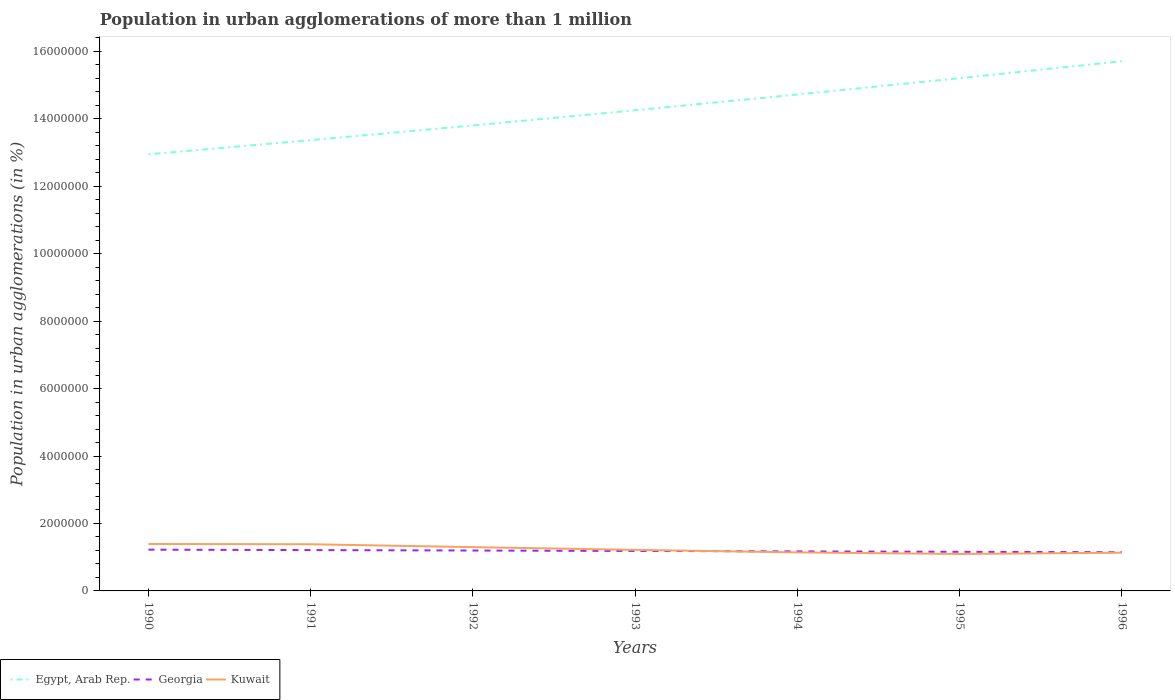How many different coloured lines are there?
Give a very brief answer. 3. Does the line corresponding to Kuwait intersect with the line corresponding to Egypt, Arab Rep.?
Your answer should be very brief. No. Is the number of lines equal to the number of legend labels?
Make the answer very short. Yes. Across all years, what is the maximum population in urban agglomerations in Egypt, Arab Rep.?
Make the answer very short. 1.29e+07. In which year was the population in urban agglomerations in Kuwait maximum?
Give a very brief answer. 1995. What is the total population in urban agglomerations in Georgia in the graph?
Keep it short and to the point. 1.29e+04. What is the difference between the highest and the second highest population in urban agglomerations in Egypt, Arab Rep.?
Offer a terse response. 2.76e+06. What is the difference between the highest and the lowest population in urban agglomerations in Georgia?
Provide a short and direct response. 3. Is the population in urban agglomerations in Kuwait strictly greater than the population in urban agglomerations in Egypt, Arab Rep. over the years?
Offer a very short reply. Yes. How many lines are there?
Give a very brief answer. 3. How many years are there in the graph?
Offer a terse response. 7. Are the values on the major ticks of Y-axis written in scientific E-notation?
Your answer should be very brief. No. How many legend labels are there?
Your answer should be compact. 3. What is the title of the graph?
Your answer should be very brief. Population in urban agglomerations of more than 1 million. What is the label or title of the Y-axis?
Provide a short and direct response. Population in urban agglomerations (in %). What is the Population in urban agglomerations (in %) in Egypt, Arab Rep. in 1990?
Make the answer very short. 1.29e+07. What is the Population in urban agglomerations (in %) in Georgia in 1990?
Give a very brief answer. 1.22e+06. What is the Population in urban agglomerations (in %) of Kuwait in 1990?
Your response must be concise. 1.39e+06. What is the Population in urban agglomerations (in %) in Egypt, Arab Rep. in 1991?
Offer a terse response. 1.34e+07. What is the Population in urban agglomerations (in %) in Georgia in 1991?
Give a very brief answer. 1.21e+06. What is the Population in urban agglomerations (in %) in Kuwait in 1991?
Give a very brief answer. 1.38e+06. What is the Population in urban agglomerations (in %) in Egypt, Arab Rep. in 1992?
Provide a succinct answer. 1.38e+07. What is the Population in urban agglomerations (in %) of Georgia in 1992?
Ensure brevity in your answer.  1.20e+06. What is the Population in urban agglomerations (in %) of Kuwait in 1992?
Your response must be concise. 1.30e+06. What is the Population in urban agglomerations (in %) of Egypt, Arab Rep. in 1993?
Provide a short and direct response. 1.43e+07. What is the Population in urban agglomerations (in %) in Georgia in 1993?
Your answer should be compact. 1.19e+06. What is the Population in urban agglomerations (in %) in Kuwait in 1993?
Offer a very short reply. 1.22e+06. What is the Population in urban agglomerations (in %) of Egypt, Arab Rep. in 1994?
Your response must be concise. 1.47e+07. What is the Population in urban agglomerations (in %) in Georgia in 1994?
Your response must be concise. 1.17e+06. What is the Population in urban agglomerations (in %) of Kuwait in 1994?
Offer a terse response. 1.14e+06. What is the Population in urban agglomerations (in %) in Egypt, Arab Rep. in 1995?
Your answer should be compact. 1.52e+07. What is the Population in urban agglomerations (in %) of Georgia in 1995?
Make the answer very short. 1.16e+06. What is the Population in urban agglomerations (in %) in Kuwait in 1995?
Your response must be concise. 1.10e+06. What is the Population in urban agglomerations (in %) in Egypt, Arab Rep. in 1996?
Your answer should be compact. 1.57e+07. What is the Population in urban agglomerations (in %) in Georgia in 1996?
Offer a very short reply. 1.15e+06. What is the Population in urban agglomerations (in %) in Kuwait in 1996?
Offer a terse response. 1.13e+06. Across all years, what is the maximum Population in urban agglomerations (in %) of Egypt, Arab Rep.?
Give a very brief answer. 1.57e+07. Across all years, what is the maximum Population in urban agglomerations (in %) of Georgia?
Keep it short and to the point. 1.22e+06. Across all years, what is the maximum Population in urban agglomerations (in %) in Kuwait?
Your answer should be very brief. 1.39e+06. Across all years, what is the minimum Population in urban agglomerations (in %) of Egypt, Arab Rep.?
Make the answer very short. 1.29e+07. Across all years, what is the minimum Population in urban agglomerations (in %) in Georgia?
Keep it short and to the point. 1.15e+06. Across all years, what is the minimum Population in urban agglomerations (in %) of Kuwait?
Make the answer very short. 1.10e+06. What is the total Population in urban agglomerations (in %) in Egypt, Arab Rep. in the graph?
Make the answer very short. 1.00e+08. What is the total Population in urban agglomerations (in %) of Georgia in the graph?
Offer a very short reply. 8.30e+06. What is the total Population in urban agglomerations (in %) in Kuwait in the graph?
Keep it short and to the point. 8.66e+06. What is the difference between the Population in urban agglomerations (in %) of Egypt, Arab Rep. in 1990 and that in 1991?
Your answer should be very brief. -4.20e+05. What is the difference between the Population in urban agglomerations (in %) in Georgia in 1990 and that in 1991?
Your response must be concise. 1.30e+04. What is the difference between the Population in urban agglomerations (in %) in Kuwait in 1990 and that in 1991?
Provide a short and direct response. 7756. What is the difference between the Population in urban agglomerations (in %) in Egypt, Arab Rep. in 1990 and that in 1992?
Provide a short and direct response. -8.55e+05. What is the difference between the Population in urban agglomerations (in %) of Georgia in 1990 and that in 1992?
Offer a terse response. 2.59e+04. What is the difference between the Population in urban agglomerations (in %) of Kuwait in 1990 and that in 1992?
Offer a very short reply. 9.37e+04. What is the difference between the Population in urban agglomerations (in %) of Egypt, Arab Rep. in 1990 and that in 1993?
Your answer should be very brief. -1.31e+06. What is the difference between the Population in urban agglomerations (in %) of Georgia in 1990 and that in 1993?
Offer a very short reply. 3.86e+04. What is the difference between the Population in urban agglomerations (in %) in Kuwait in 1990 and that in 1993?
Provide a short and direct response. 1.74e+05. What is the difference between the Population in urban agglomerations (in %) in Egypt, Arab Rep. in 1990 and that in 1994?
Your answer should be very brief. -1.77e+06. What is the difference between the Population in urban agglomerations (in %) in Georgia in 1990 and that in 1994?
Ensure brevity in your answer.  5.12e+04. What is the difference between the Population in urban agglomerations (in %) of Kuwait in 1990 and that in 1994?
Make the answer very short. 2.50e+05. What is the difference between the Population in urban agglomerations (in %) in Egypt, Arab Rep. in 1990 and that in 1995?
Offer a terse response. -2.26e+06. What is the difference between the Population in urban agglomerations (in %) in Georgia in 1990 and that in 1995?
Make the answer very short. 6.37e+04. What is the difference between the Population in urban agglomerations (in %) in Kuwait in 1990 and that in 1995?
Provide a short and direct response. 2.97e+05. What is the difference between the Population in urban agglomerations (in %) of Egypt, Arab Rep. in 1990 and that in 1996?
Provide a succinct answer. -2.76e+06. What is the difference between the Population in urban agglomerations (in %) of Georgia in 1990 and that in 1996?
Give a very brief answer. 7.60e+04. What is the difference between the Population in urban agglomerations (in %) of Kuwait in 1990 and that in 1996?
Offer a terse response. 2.58e+05. What is the difference between the Population in urban agglomerations (in %) in Egypt, Arab Rep. in 1991 and that in 1992?
Your answer should be compact. -4.36e+05. What is the difference between the Population in urban agglomerations (in %) in Georgia in 1991 and that in 1992?
Offer a very short reply. 1.29e+04. What is the difference between the Population in urban agglomerations (in %) in Kuwait in 1991 and that in 1992?
Make the answer very short. 8.60e+04. What is the difference between the Population in urban agglomerations (in %) in Egypt, Arab Rep. in 1991 and that in 1993?
Your response must be concise. -8.86e+05. What is the difference between the Population in urban agglomerations (in %) in Georgia in 1991 and that in 1993?
Give a very brief answer. 2.56e+04. What is the difference between the Population in urban agglomerations (in %) of Kuwait in 1991 and that in 1993?
Give a very brief answer. 1.66e+05. What is the difference between the Population in urban agglomerations (in %) of Egypt, Arab Rep. in 1991 and that in 1994?
Offer a terse response. -1.35e+06. What is the difference between the Population in urban agglomerations (in %) of Georgia in 1991 and that in 1994?
Ensure brevity in your answer.  3.82e+04. What is the difference between the Population in urban agglomerations (in %) of Kuwait in 1991 and that in 1994?
Keep it short and to the point. 2.42e+05. What is the difference between the Population in urban agglomerations (in %) in Egypt, Arab Rep. in 1991 and that in 1995?
Offer a very short reply. -1.84e+06. What is the difference between the Population in urban agglomerations (in %) of Georgia in 1991 and that in 1995?
Keep it short and to the point. 5.07e+04. What is the difference between the Population in urban agglomerations (in %) in Kuwait in 1991 and that in 1995?
Provide a succinct answer. 2.89e+05. What is the difference between the Population in urban agglomerations (in %) in Egypt, Arab Rep. in 1991 and that in 1996?
Keep it short and to the point. -2.34e+06. What is the difference between the Population in urban agglomerations (in %) of Georgia in 1991 and that in 1996?
Ensure brevity in your answer.  6.30e+04. What is the difference between the Population in urban agglomerations (in %) of Kuwait in 1991 and that in 1996?
Offer a very short reply. 2.51e+05. What is the difference between the Population in urban agglomerations (in %) in Egypt, Arab Rep. in 1992 and that in 1993?
Offer a very short reply. -4.50e+05. What is the difference between the Population in urban agglomerations (in %) of Georgia in 1992 and that in 1993?
Provide a succinct answer. 1.27e+04. What is the difference between the Population in urban agglomerations (in %) in Kuwait in 1992 and that in 1993?
Keep it short and to the point. 8.04e+04. What is the difference between the Population in urban agglomerations (in %) in Egypt, Arab Rep. in 1992 and that in 1994?
Keep it short and to the point. -9.18e+05. What is the difference between the Population in urban agglomerations (in %) in Georgia in 1992 and that in 1994?
Your response must be concise. 2.53e+04. What is the difference between the Population in urban agglomerations (in %) in Kuwait in 1992 and that in 1994?
Your response must be concise. 1.56e+05. What is the difference between the Population in urban agglomerations (in %) in Egypt, Arab Rep. in 1992 and that in 1995?
Your answer should be very brief. -1.40e+06. What is the difference between the Population in urban agglomerations (in %) of Georgia in 1992 and that in 1995?
Keep it short and to the point. 3.78e+04. What is the difference between the Population in urban agglomerations (in %) of Kuwait in 1992 and that in 1995?
Offer a terse response. 2.03e+05. What is the difference between the Population in urban agglomerations (in %) of Egypt, Arab Rep. in 1992 and that in 1996?
Give a very brief answer. -1.91e+06. What is the difference between the Population in urban agglomerations (in %) in Georgia in 1992 and that in 1996?
Provide a short and direct response. 5.01e+04. What is the difference between the Population in urban agglomerations (in %) of Kuwait in 1992 and that in 1996?
Offer a very short reply. 1.65e+05. What is the difference between the Population in urban agglomerations (in %) in Egypt, Arab Rep. in 1993 and that in 1994?
Your answer should be compact. -4.67e+05. What is the difference between the Population in urban agglomerations (in %) in Georgia in 1993 and that in 1994?
Give a very brief answer. 1.26e+04. What is the difference between the Population in urban agglomerations (in %) of Kuwait in 1993 and that in 1994?
Provide a succinct answer. 7.55e+04. What is the difference between the Population in urban agglomerations (in %) of Egypt, Arab Rep. in 1993 and that in 1995?
Give a very brief answer. -9.52e+05. What is the difference between the Population in urban agglomerations (in %) in Georgia in 1993 and that in 1995?
Provide a succinct answer. 2.51e+04. What is the difference between the Population in urban agglomerations (in %) of Kuwait in 1993 and that in 1995?
Your answer should be very brief. 1.22e+05. What is the difference between the Population in urban agglomerations (in %) of Egypt, Arab Rep. in 1993 and that in 1996?
Offer a terse response. -1.45e+06. What is the difference between the Population in urban agglomerations (in %) of Georgia in 1993 and that in 1996?
Your response must be concise. 3.74e+04. What is the difference between the Population in urban agglomerations (in %) of Kuwait in 1993 and that in 1996?
Ensure brevity in your answer.  8.42e+04. What is the difference between the Population in urban agglomerations (in %) of Egypt, Arab Rep. in 1994 and that in 1995?
Your answer should be compact. -4.84e+05. What is the difference between the Population in urban agglomerations (in %) of Georgia in 1994 and that in 1995?
Give a very brief answer. 1.25e+04. What is the difference between the Population in urban agglomerations (in %) of Kuwait in 1994 and that in 1995?
Your answer should be very brief. 4.69e+04. What is the difference between the Population in urban agglomerations (in %) of Egypt, Arab Rep. in 1994 and that in 1996?
Provide a short and direct response. -9.87e+05. What is the difference between the Population in urban agglomerations (in %) in Georgia in 1994 and that in 1996?
Offer a terse response. 2.48e+04. What is the difference between the Population in urban agglomerations (in %) in Kuwait in 1994 and that in 1996?
Provide a succinct answer. 8671. What is the difference between the Population in urban agglomerations (in %) of Egypt, Arab Rep. in 1995 and that in 1996?
Ensure brevity in your answer.  -5.03e+05. What is the difference between the Population in urban agglomerations (in %) of Georgia in 1995 and that in 1996?
Give a very brief answer. 1.23e+04. What is the difference between the Population in urban agglomerations (in %) of Kuwait in 1995 and that in 1996?
Provide a short and direct response. -3.82e+04. What is the difference between the Population in urban agglomerations (in %) of Egypt, Arab Rep. in 1990 and the Population in urban agglomerations (in %) of Georgia in 1991?
Your answer should be compact. 1.17e+07. What is the difference between the Population in urban agglomerations (in %) of Egypt, Arab Rep. in 1990 and the Population in urban agglomerations (in %) of Kuwait in 1991?
Your response must be concise. 1.16e+07. What is the difference between the Population in urban agglomerations (in %) of Georgia in 1990 and the Population in urban agglomerations (in %) of Kuwait in 1991?
Offer a very short reply. -1.60e+05. What is the difference between the Population in urban agglomerations (in %) of Egypt, Arab Rep. in 1990 and the Population in urban agglomerations (in %) of Georgia in 1992?
Your answer should be compact. 1.18e+07. What is the difference between the Population in urban agglomerations (in %) of Egypt, Arab Rep. in 1990 and the Population in urban agglomerations (in %) of Kuwait in 1992?
Offer a terse response. 1.16e+07. What is the difference between the Population in urban agglomerations (in %) in Georgia in 1990 and the Population in urban agglomerations (in %) in Kuwait in 1992?
Make the answer very short. -7.43e+04. What is the difference between the Population in urban agglomerations (in %) in Egypt, Arab Rep. in 1990 and the Population in urban agglomerations (in %) in Georgia in 1993?
Your response must be concise. 1.18e+07. What is the difference between the Population in urban agglomerations (in %) of Egypt, Arab Rep. in 1990 and the Population in urban agglomerations (in %) of Kuwait in 1993?
Ensure brevity in your answer.  1.17e+07. What is the difference between the Population in urban agglomerations (in %) in Georgia in 1990 and the Population in urban agglomerations (in %) in Kuwait in 1993?
Ensure brevity in your answer.  6080. What is the difference between the Population in urban agglomerations (in %) of Egypt, Arab Rep. in 1990 and the Population in urban agglomerations (in %) of Georgia in 1994?
Offer a very short reply. 1.18e+07. What is the difference between the Population in urban agglomerations (in %) in Egypt, Arab Rep. in 1990 and the Population in urban agglomerations (in %) in Kuwait in 1994?
Your answer should be very brief. 1.18e+07. What is the difference between the Population in urban agglomerations (in %) of Georgia in 1990 and the Population in urban agglomerations (in %) of Kuwait in 1994?
Your response must be concise. 8.16e+04. What is the difference between the Population in urban agglomerations (in %) in Egypt, Arab Rep. in 1990 and the Population in urban agglomerations (in %) in Georgia in 1995?
Keep it short and to the point. 1.18e+07. What is the difference between the Population in urban agglomerations (in %) in Egypt, Arab Rep. in 1990 and the Population in urban agglomerations (in %) in Kuwait in 1995?
Ensure brevity in your answer.  1.19e+07. What is the difference between the Population in urban agglomerations (in %) of Georgia in 1990 and the Population in urban agglomerations (in %) of Kuwait in 1995?
Keep it short and to the point. 1.29e+05. What is the difference between the Population in urban agglomerations (in %) in Egypt, Arab Rep. in 1990 and the Population in urban agglomerations (in %) in Georgia in 1996?
Offer a terse response. 1.18e+07. What is the difference between the Population in urban agglomerations (in %) of Egypt, Arab Rep. in 1990 and the Population in urban agglomerations (in %) of Kuwait in 1996?
Offer a very short reply. 1.18e+07. What is the difference between the Population in urban agglomerations (in %) in Georgia in 1990 and the Population in urban agglomerations (in %) in Kuwait in 1996?
Your answer should be very brief. 9.03e+04. What is the difference between the Population in urban agglomerations (in %) in Egypt, Arab Rep. in 1991 and the Population in urban agglomerations (in %) in Georgia in 1992?
Make the answer very short. 1.22e+07. What is the difference between the Population in urban agglomerations (in %) in Egypt, Arab Rep. in 1991 and the Population in urban agglomerations (in %) in Kuwait in 1992?
Make the answer very short. 1.21e+07. What is the difference between the Population in urban agglomerations (in %) of Georgia in 1991 and the Population in urban agglomerations (in %) of Kuwait in 1992?
Make the answer very short. -8.73e+04. What is the difference between the Population in urban agglomerations (in %) of Egypt, Arab Rep. in 1991 and the Population in urban agglomerations (in %) of Georgia in 1993?
Provide a succinct answer. 1.22e+07. What is the difference between the Population in urban agglomerations (in %) of Egypt, Arab Rep. in 1991 and the Population in urban agglomerations (in %) of Kuwait in 1993?
Your response must be concise. 1.22e+07. What is the difference between the Population in urban agglomerations (in %) of Georgia in 1991 and the Population in urban agglomerations (in %) of Kuwait in 1993?
Provide a succinct answer. -6927. What is the difference between the Population in urban agglomerations (in %) of Egypt, Arab Rep. in 1991 and the Population in urban agglomerations (in %) of Georgia in 1994?
Your response must be concise. 1.22e+07. What is the difference between the Population in urban agglomerations (in %) of Egypt, Arab Rep. in 1991 and the Population in urban agglomerations (in %) of Kuwait in 1994?
Keep it short and to the point. 1.22e+07. What is the difference between the Population in urban agglomerations (in %) in Georgia in 1991 and the Population in urban agglomerations (in %) in Kuwait in 1994?
Keep it short and to the point. 6.86e+04. What is the difference between the Population in urban agglomerations (in %) of Egypt, Arab Rep. in 1991 and the Population in urban agglomerations (in %) of Georgia in 1995?
Give a very brief answer. 1.22e+07. What is the difference between the Population in urban agglomerations (in %) of Egypt, Arab Rep. in 1991 and the Population in urban agglomerations (in %) of Kuwait in 1995?
Offer a very short reply. 1.23e+07. What is the difference between the Population in urban agglomerations (in %) in Georgia in 1991 and the Population in urban agglomerations (in %) in Kuwait in 1995?
Offer a very short reply. 1.16e+05. What is the difference between the Population in urban agglomerations (in %) in Egypt, Arab Rep. in 1991 and the Population in urban agglomerations (in %) in Georgia in 1996?
Give a very brief answer. 1.22e+07. What is the difference between the Population in urban agglomerations (in %) in Egypt, Arab Rep. in 1991 and the Population in urban agglomerations (in %) in Kuwait in 1996?
Offer a terse response. 1.22e+07. What is the difference between the Population in urban agglomerations (in %) of Georgia in 1991 and the Population in urban agglomerations (in %) of Kuwait in 1996?
Ensure brevity in your answer.  7.73e+04. What is the difference between the Population in urban agglomerations (in %) of Egypt, Arab Rep. in 1992 and the Population in urban agglomerations (in %) of Georgia in 1993?
Your answer should be very brief. 1.26e+07. What is the difference between the Population in urban agglomerations (in %) of Egypt, Arab Rep. in 1992 and the Population in urban agglomerations (in %) of Kuwait in 1993?
Make the answer very short. 1.26e+07. What is the difference between the Population in urban agglomerations (in %) in Georgia in 1992 and the Population in urban agglomerations (in %) in Kuwait in 1993?
Keep it short and to the point. -1.98e+04. What is the difference between the Population in urban agglomerations (in %) of Egypt, Arab Rep. in 1992 and the Population in urban agglomerations (in %) of Georgia in 1994?
Ensure brevity in your answer.  1.26e+07. What is the difference between the Population in urban agglomerations (in %) of Egypt, Arab Rep. in 1992 and the Population in urban agglomerations (in %) of Kuwait in 1994?
Your response must be concise. 1.27e+07. What is the difference between the Population in urban agglomerations (in %) in Georgia in 1992 and the Population in urban agglomerations (in %) in Kuwait in 1994?
Offer a terse response. 5.57e+04. What is the difference between the Population in urban agglomerations (in %) of Egypt, Arab Rep. in 1992 and the Population in urban agglomerations (in %) of Georgia in 1995?
Ensure brevity in your answer.  1.26e+07. What is the difference between the Population in urban agglomerations (in %) in Egypt, Arab Rep. in 1992 and the Population in urban agglomerations (in %) in Kuwait in 1995?
Provide a succinct answer. 1.27e+07. What is the difference between the Population in urban agglomerations (in %) of Georgia in 1992 and the Population in urban agglomerations (in %) of Kuwait in 1995?
Your answer should be very brief. 1.03e+05. What is the difference between the Population in urban agglomerations (in %) in Egypt, Arab Rep. in 1992 and the Population in urban agglomerations (in %) in Georgia in 1996?
Offer a terse response. 1.27e+07. What is the difference between the Population in urban agglomerations (in %) in Egypt, Arab Rep. in 1992 and the Population in urban agglomerations (in %) in Kuwait in 1996?
Keep it short and to the point. 1.27e+07. What is the difference between the Population in urban agglomerations (in %) in Georgia in 1992 and the Population in urban agglomerations (in %) in Kuwait in 1996?
Make the answer very short. 6.44e+04. What is the difference between the Population in urban agglomerations (in %) of Egypt, Arab Rep. in 1993 and the Population in urban agglomerations (in %) of Georgia in 1994?
Your answer should be very brief. 1.31e+07. What is the difference between the Population in urban agglomerations (in %) of Egypt, Arab Rep. in 1993 and the Population in urban agglomerations (in %) of Kuwait in 1994?
Give a very brief answer. 1.31e+07. What is the difference between the Population in urban agglomerations (in %) in Georgia in 1993 and the Population in urban agglomerations (in %) in Kuwait in 1994?
Offer a very short reply. 4.30e+04. What is the difference between the Population in urban agglomerations (in %) of Egypt, Arab Rep. in 1993 and the Population in urban agglomerations (in %) of Georgia in 1995?
Your answer should be very brief. 1.31e+07. What is the difference between the Population in urban agglomerations (in %) in Egypt, Arab Rep. in 1993 and the Population in urban agglomerations (in %) in Kuwait in 1995?
Provide a succinct answer. 1.32e+07. What is the difference between the Population in urban agglomerations (in %) of Georgia in 1993 and the Population in urban agglomerations (in %) of Kuwait in 1995?
Keep it short and to the point. 8.99e+04. What is the difference between the Population in urban agglomerations (in %) in Egypt, Arab Rep. in 1993 and the Population in urban agglomerations (in %) in Georgia in 1996?
Keep it short and to the point. 1.31e+07. What is the difference between the Population in urban agglomerations (in %) of Egypt, Arab Rep. in 1993 and the Population in urban agglomerations (in %) of Kuwait in 1996?
Provide a succinct answer. 1.31e+07. What is the difference between the Population in urban agglomerations (in %) in Georgia in 1993 and the Population in urban agglomerations (in %) in Kuwait in 1996?
Keep it short and to the point. 5.17e+04. What is the difference between the Population in urban agglomerations (in %) of Egypt, Arab Rep. in 1994 and the Population in urban agglomerations (in %) of Georgia in 1995?
Your answer should be compact. 1.36e+07. What is the difference between the Population in urban agglomerations (in %) in Egypt, Arab Rep. in 1994 and the Population in urban agglomerations (in %) in Kuwait in 1995?
Your answer should be very brief. 1.36e+07. What is the difference between the Population in urban agglomerations (in %) in Georgia in 1994 and the Population in urban agglomerations (in %) in Kuwait in 1995?
Offer a very short reply. 7.73e+04. What is the difference between the Population in urban agglomerations (in %) of Egypt, Arab Rep. in 1994 and the Population in urban agglomerations (in %) of Georgia in 1996?
Give a very brief answer. 1.36e+07. What is the difference between the Population in urban agglomerations (in %) in Egypt, Arab Rep. in 1994 and the Population in urban agglomerations (in %) in Kuwait in 1996?
Offer a very short reply. 1.36e+07. What is the difference between the Population in urban agglomerations (in %) in Georgia in 1994 and the Population in urban agglomerations (in %) in Kuwait in 1996?
Your answer should be very brief. 3.91e+04. What is the difference between the Population in urban agglomerations (in %) of Egypt, Arab Rep. in 1995 and the Population in urban agglomerations (in %) of Georgia in 1996?
Make the answer very short. 1.41e+07. What is the difference between the Population in urban agglomerations (in %) of Egypt, Arab Rep. in 1995 and the Population in urban agglomerations (in %) of Kuwait in 1996?
Make the answer very short. 1.41e+07. What is the difference between the Population in urban agglomerations (in %) in Georgia in 1995 and the Population in urban agglomerations (in %) in Kuwait in 1996?
Ensure brevity in your answer.  2.66e+04. What is the average Population in urban agglomerations (in %) of Egypt, Arab Rep. per year?
Your answer should be very brief. 1.43e+07. What is the average Population in urban agglomerations (in %) in Georgia per year?
Make the answer very short. 1.19e+06. What is the average Population in urban agglomerations (in %) in Kuwait per year?
Provide a short and direct response. 1.24e+06. In the year 1990, what is the difference between the Population in urban agglomerations (in %) of Egypt, Arab Rep. and Population in urban agglomerations (in %) of Georgia?
Your answer should be very brief. 1.17e+07. In the year 1990, what is the difference between the Population in urban agglomerations (in %) of Egypt, Arab Rep. and Population in urban agglomerations (in %) of Kuwait?
Provide a succinct answer. 1.16e+07. In the year 1990, what is the difference between the Population in urban agglomerations (in %) in Georgia and Population in urban agglomerations (in %) in Kuwait?
Ensure brevity in your answer.  -1.68e+05. In the year 1991, what is the difference between the Population in urban agglomerations (in %) in Egypt, Arab Rep. and Population in urban agglomerations (in %) in Georgia?
Give a very brief answer. 1.22e+07. In the year 1991, what is the difference between the Population in urban agglomerations (in %) in Egypt, Arab Rep. and Population in urban agglomerations (in %) in Kuwait?
Keep it short and to the point. 1.20e+07. In the year 1991, what is the difference between the Population in urban agglomerations (in %) of Georgia and Population in urban agglomerations (in %) of Kuwait?
Provide a short and direct response. -1.73e+05. In the year 1992, what is the difference between the Population in urban agglomerations (in %) in Egypt, Arab Rep. and Population in urban agglomerations (in %) in Georgia?
Ensure brevity in your answer.  1.26e+07. In the year 1992, what is the difference between the Population in urban agglomerations (in %) in Egypt, Arab Rep. and Population in urban agglomerations (in %) in Kuwait?
Keep it short and to the point. 1.25e+07. In the year 1992, what is the difference between the Population in urban agglomerations (in %) in Georgia and Population in urban agglomerations (in %) in Kuwait?
Your answer should be very brief. -1.00e+05. In the year 1993, what is the difference between the Population in urban agglomerations (in %) in Egypt, Arab Rep. and Population in urban agglomerations (in %) in Georgia?
Ensure brevity in your answer.  1.31e+07. In the year 1993, what is the difference between the Population in urban agglomerations (in %) in Egypt, Arab Rep. and Population in urban agglomerations (in %) in Kuwait?
Your answer should be very brief. 1.30e+07. In the year 1993, what is the difference between the Population in urban agglomerations (in %) of Georgia and Population in urban agglomerations (in %) of Kuwait?
Your answer should be very brief. -3.25e+04. In the year 1994, what is the difference between the Population in urban agglomerations (in %) of Egypt, Arab Rep. and Population in urban agglomerations (in %) of Georgia?
Your response must be concise. 1.35e+07. In the year 1994, what is the difference between the Population in urban agglomerations (in %) in Egypt, Arab Rep. and Population in urban agglomerations (in %) in Kuwait?
Offer a terse response. 1.36e+07. In the year 1994, what is the difference between the Population in urban agglomerations (in %) of Georgia and Population in urban agglomerations (in %) of Kuwait?
Keep it short and to the point. 3.04e+04. In the year 1995, what is the difference between the Population in urban agglomerations (in %) of Egypt, Arab Rep. and Population in urban agglomerations (in %) of Georgia?
Make the answer very short. 1.40e+07. In the year 1995, what is the difference between the Population in urban agglomerations (in %) in Egypt, Arab Rep. and Population in urban agglomerations (in %) in Kuwait?
Your answer should be compact. 1.41e+07. In the year 1995, what is the difference between the Population in urban agglomerations (in %) in Georgia and Population in urban agglomerations (in %) in Kuwait?
Make the answer very short. 6.49e+04. In the year 1996, what is the difference between the Population in urban agglomerations (in %) in Egypt, Arab Rep. and Population in urban agglomerations (in %) in Georgia?
Your answer should be compact. 1.46e+07. In the year 1996, what is the difference between the Population in urban agglomerations (in %) in Egypt, Arab Rep. and Population in urban agglomerations (in %) in Kuwait?
Keep it short and to the point. 1.46e+07. In the year 1996, what is the difference between the Population in urban agglomerations (in %) in Georgia and Population in urban agglomerations (in %) in Kuwait?
Your answer should be compact. 1.43e+04. What is the ratio of the Population in urban agglomerations (in %) in Egypt, Arab Rep. in 1990 to that in 1991?
Provide a short and direct response. 0.97. What is the ratio of the Population in urban agglomerations (in %) in Georgia in 1990 to that in 1991?
Ensure brevity in your answer.  1.01. What is the ratio of the Population in urban agglomerations (in %) of Kuwait in 1990 to that in 1991?
Make the answer very short. 1.01. What is the ratio of the Population in urban agglomerations (in %) in Egypt, Arab Rep. in 1990 to that in 1992?
Ensure brevity in your answer.  0.94. What is the ratio of the Population in urban agglomerations (in %) of Georgia in 1990 to that in 1992?
Keep it short and to the point. 1.02. What is the ratio of the Population in urban agglomerations (in %) of Kuwait in 1990 to that in 1992?
Provide a short and direct response. 1.07. What is the ratio of the Population in urban agglomerations (in %) in Egypt, Arab Rep. in 1990 to that in 1993?
Offer a very short reply. 0.91. What is the ratio of the Population in urban agglomerations (in %) of Georgia in 1990 to that in 1993?
Keep it short and to the point. 1.03. What is the ratio of the Population in urban agglomerations (in %) in Kuwait in 1990 to that in 1993?
Offer a very short reply. 1.14. What is the ratio of the Population in urban agglomerations (in %) in Egypt, Arab Rep. in 1990 to that in 1994?
Your answer should be compact. 0.88. What is the ratio of the Population in urban agglomerations (in %) of Georgia in 1990 to that in 1994?
Keep it short and to the point. 1.04. What is the ratio of the Population in urban agglomerations (in %) in Kuwait in 1990 to that in 1994?
Your answer should be compact. 1.22. What is the ratio of the Population in urban agglomerations (in %) of Egypt, Arab Rep. in 1990 to that in 1995?
Provide a succinct answer. 0.85. What is the ratio of the Population in urban agglomerations (in %) in Georgia in 1990 to that in 1995?
Ensure brevity in your answer.  1.05. What is the ratio of the Population in urban agglomerations (in %) in Kuwait in 1990 to that in 1995?
Your answer should be compact. 1.27. What is the ratio of the Population in urban agglomerations (in %) in Egypt, Arab Rep. in 1990 to that in 1996?
Ensure brevity in your answer.  0.82. What is the ratio of the Population in urban agglomerations (in %) in Georgia in 1990 to that in 1996?
Provide a succinct answer. 1.07. What is the ratio of the Population in urban agglomerations (in %) of Kuwait in 1990 to that in 1996?
Your answer should be compact. 1.23. What is the ratio of the Population in urban agglomerations (in %) of Egypt, Arab Rep. in 1991 to that in 1992?
Provide a short and direct response. 0.97. What is the ratio of the Population in urban agglomerations (in %) of Georgia in 1991 to that in 1992?
Your answer should be compact. 1.01. What is the ratio of the Population in urban agglomerations (in %) in Kuwait in 1991 to that in 1992?
Provide a succinct answer. 1.07. What is the ratio of the Population in urban agglomerations (in %) of Egypt, Arab Rep. in 1991 to that in 1993?
Give a very brief answer. 0.94. What is the ratio of the Population in urban agglomerations (in %) of Georgia in 1991 to that in 1993?
Offer a very short reply. 1.02. What is the ratio of the Population in urban agglomerations (in %) in Kuwait in 1991 to that in 1993?
Offer a very short reply. 1.14. What is the ratio of the Population in urban agglomerations (in %) in Egypt, Arab Rep. in 1991 to that in 1994?
Provide a short and direct response. 0.91. What is the ratio of the Population in urban agglomerations (in %) in Georgia in 1991 to that in 1994?
Your response must be concise. 1.03. What is the ratio of the Population in urban agglomerations (in %) of Kuwait in 1991 to that in 1994?
Your response must be concise. 1.21. What is the ratio of the Population in urban agglomerations (in %) of Egypt, Arab Rep. in 1991 to that in 1995?
Your response must be concise. 0.88. What is the ratio of the Population in urban agglomerations (in %) in Georgia in 1991 to that in 1995?
Offer a very short reply. 1.04. What is the ratio of the Population in urban agglomerations (in %) in Kuwait in 1991 to that in 1995?
Offer a very short reply. 1.26. What is the ratio of the Population in urban agglomerations (in %) of Egypt, Arab Rep. in 1991 to that in 1996?
Keep it short and to the point. 0.85. What is the ratio of the Population in urban agglomerations (in %) of Georgia in 1991 to that in 1996?
Offer a very short reply. 1.05. What is the ratio of the Population in urban agglomerations (in %) in Kuwait in 1991 to that in 1996?
Offer a terse response. 1.22. What is the ratio of the Population in urban agglomerations (in %) in Egypt, Arab Rep. in 1992 to that in 1993?
Keep it short and to the point. 0.97. What is the ratio of the Population in urban agglomerations (in %) of Georgia in 1992 to that in 1993?
Offer a terse response. 1.01. What is the ratio of the Population in urban agglomerations (in %) of Kuwait in 1992 to that in 1993?
Provide a succinct answer. 1.07. What is the ratio of the Population in urban agglomerations (in %) of Egypt, Arab Rep. in 1992 to that in 1994?
Your answer should be compact. 0.94. What is the ratio of the Population in urban agglomerations (in %) in Georgia in 1992 to that in 1994?
Give a very brief answer. 1.02. What is the ratio of the Population in urban agglomerations (in %) of Kuwait in 1992 to that in 1994?
Ensure brevity in your answer.  1.14. What is the ratio of the Population in urban agglomerations (in %) of Egypt, Arab Rep. in 1992 to that in 1995?
Ensure brevity in your answer.  0.91. What is the ratio of the Population in urban agglomerations (in %) of Georgia in 1992 to that in 1995?
Keep it short and to the point. 1.03. What is the ratio of the Population in urban agglomerations (in %) in Kuwait in 1992 to that in 1995?
Provide a short and direct response. 1.19. What is the ratio of the Population in urban agglomerations (in %) in Egypt, Arab Rep. in 1992 to that in 1996?
Your answer should be compact. 0.88. What is the ratio of the Population in urban agglomerations (in %) in Georgia in 1992 to that in 1996?
Your answer should be compact. 1.04. What is the ratio of the Population in urban agglomerations (in %) in Kuwait in 1992 to that in 1996?
Provide a short and direct response. 1.15. What is the ratio of the Population in urban agglomerations (in %) of Egypt, Arab Rep. in 1993 to that in 1994?
Keep it short and to the point. 0.97. What is the ratio of the Population in urban agglomerations (in %) of Georgia in 1993 to that in 1994?
Make the answer very short. 1.01. What is the ratio of the Population in urban agglomerations (in %) of Kuwait in 1993 to that in 1994?
Keep it short and to the point. 1.07. What is the ratio of the Population in urban agglomerations (in %) in Egypt, Arab Rep. in 1993 to that in 1995?
Offer a terse response. 0.94. What is the ratio of the Population in urban agglomerations (in %) of Georgia in 1993 to that in 1995?
Provide a short and direct response. 1.02. What is the ratio of the Population in urban agglomerations (in %) in Kuwait in 1993 to that in 1995?
Keep it short and to the point. 1.11. What is the ratio of the Population in urban agglomerations (in %) of Egypt, Arab Rep. in 1993 to that in 1996?
Provide a succinct answer. 0.91. What is the ratio of the Population in urban agglomerations (in %) of Georgia in 1993 to that in 1996?
Offer a terse response. 1.03. What is the ratio of the Population in urban agglomerations (in %) in Kuwait in 1993 to that in 1996?
Give a very brief answer. 1.07. What is the ratio of the Population in urban agglomerations (in %) of Egypt, Arab Rep. in 1994 to that in 1995?
Your response must be concise. 0.97. What is the ratio of the Population in urban agglomerations (in %) in Georgia in 1994 to that in 1995?
Make the answer very short. 1.01. What is the ratio of the Population in urban agglomerations (in %) in Kuwait in 1994 to that in 1995?
Provide a short and direct response. 1.04. What is the ratio of the Population in urban agglomerations (in %) of Egypt, Arab Rep. in 1994 to that in 1996?
Provide a short and direct response. 0.94. What is the ratio of the Population in urban agglomerations (in %) in Georgia in 1994 to that in 1996?
Offer a very short reply. 1.02. What is the ratio of the Population in urban agglomerations (in %) in Kuwait in 1994 to that in 1996?
Keep it short and to the point. 1.01. What is the ratio of the Population in urban agglomerations (in %) of Georgia in 1995 to that in 1996?
Make the answer very short. 1.01. What is the ratio of the Population in urban agglomerations (in %) of Kuwait in 1995 to that in 1996?
Make the answer very short. 0.97. What is the difference between the highest and the second highest Population in urban agglomerations (in %) of Egypt, Arab Rep.?
Make the answer very short. 5.03e+05. What is the difference between the highest and the second highest Population in urban agglomerations (in %) in Georgia?
Provide a short and direct response. 1.30e+04. What is the difference between the highest and the second highest Population in urban agglomerations (in %) in Kuwait?
Provide a short and direct response. 7756. What is the difference between the highest and the lowest Population in urban agglomerations (in %) of Egypt, Arab Rep.?
Provide a succinct answer. 2.76e+06. What is the difference between the highest and the lowest Population in urban agglomerations (in %) in Georgia?
Your answer should be compact. 7.60e+04. What is the difference between the highest and the lowest Population in urban agglomerations (in %) of Kuwait?
Your answer should be compact. 2.97e+05. 